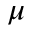<formula> <loc_0><loc_0><loc_500><loc_500>\mu</formula> 